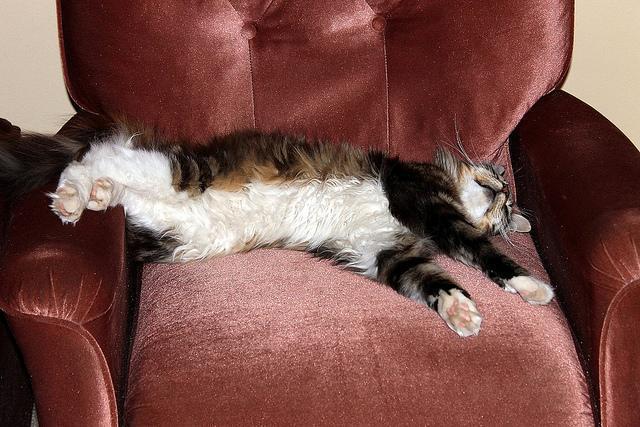How many people in the image are sitting?
Give a very brief answer. 0. 